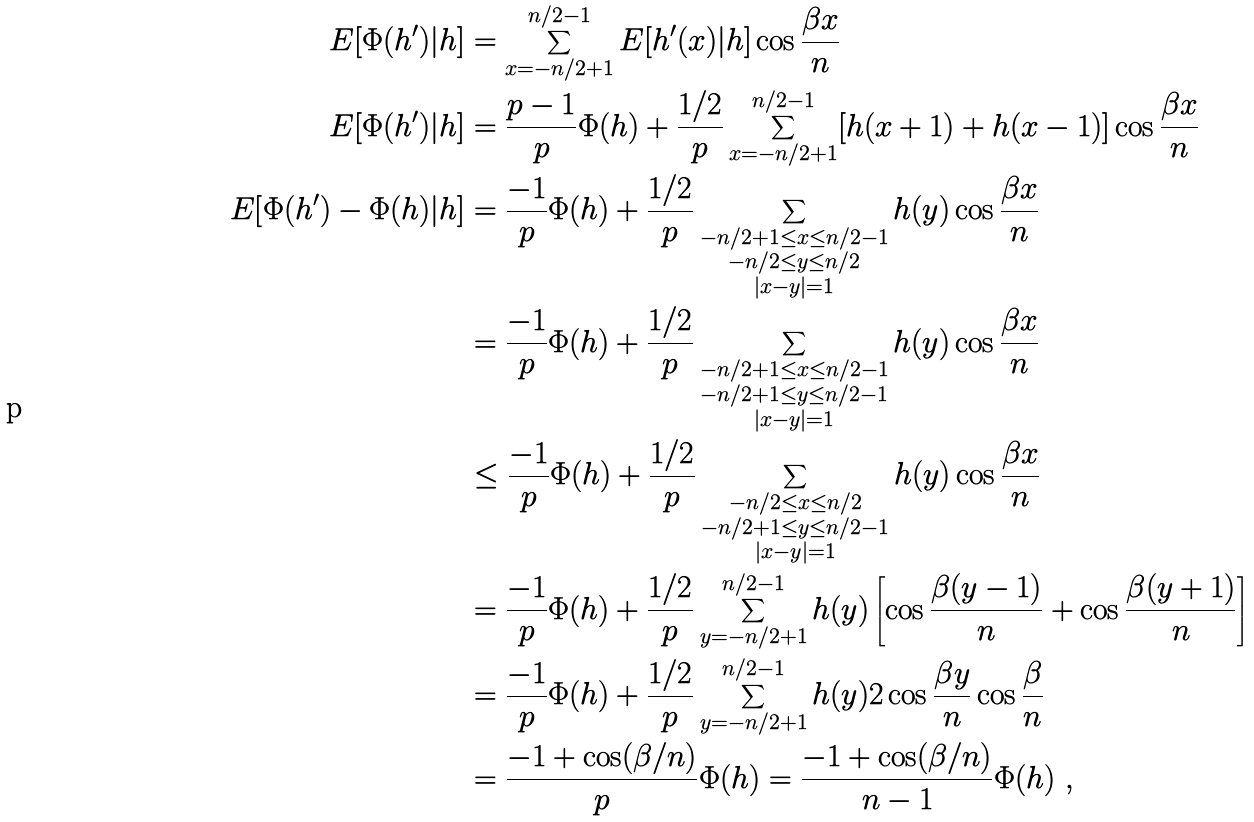Convert formula to latex. <formula><loc_0><loc_0><loc_500><loc_500>E [ \Phi ( h ^ { \prime } ) | h ] & = \sum _ { x = - n / 2 + 1 } ^ { n / 2 - 1 } E [ h ^ { \prime } ( x ) | h ] \cos \frac { \beta x } { n } \\ E [ \Phi ( h ^ { \prime } ) | h ] & = \frac { p - 1 } { p } \Phi ( h ) + \frac { 1 / 2 } { p } \sum _ { x = - n / 2 + 1 } ^ { n / 2 - 1 } [ h ( x + 1 ) + h ( x - 1 ) ] \cos \frac { \beta x } { n } \\ E [ \Phi ( h ^ { \prime } ) - \Phi ( h ) | h ] & = \frac { - 1 } { p } \Phi ( h ) + \frac { 1 / 2 } { p } \sum _ { \substack { - n / 2 + 1 \leq x \leq n / 2 - 1 \\ - n / 2 \leq y \leq n / 2 \\ | x - y | = 1 } } h ( y ) \cos \frac { \beta x } { n } \\ & = \frac { - 1 } { p } \Phi ( h ) + \frac { 1 / 2 } { p } \sum _ { \substack { - n / 2 + 1 \leq x \leq n / 2 - 1 \\ - n / 2 + 1 \leq y \leq n / 2 - 1 \\ | x - y | = 1 } } h ( y ) \cos \frac { \beta x } { n } \\ & \leq \frac { - 1 } { p } \Phi ( h ) + \frac { 1 / 2 } { p } \sum _ { \substack { - n / 2 \leq x \leq n / 2 \\ - n / 2 + 1 \leq y \leq n / 2 - 1 \\ | x - y | = 1 } } h ( y ) \cos \frac { \beta x } { n } \\ & = \frac { - 1 } { p } \Phi ( h ) + \frac { 1 / 2 } { p } \sum _ { y = - n / 2 + 1 } ^ { n / 2 - 1 } h ( y ) \left [ \cos \frac { \beta ( y - 1 ) } { n } + \cos \frac { \beta ( y + 1 ) } { n } \right ] \\ & = \frac { - 1 } { p } \Phi ( h ) + \frac { 1 / 2 } { p } \sum _ { y = - n / 2 + 1 } ^ { n / 2 - 1 } h ( y ) 2 \cos \frac { \beta y } { n } \cos \frac { \beta } { n } \\ & = \frac { - 1 + \cos ( \beta / n ) } { p } \Phi ( h ) = \frac { - 1 + \cos ( \beta / n ) } { n - 1 } \Phi ( h ) \ ,</formula> 